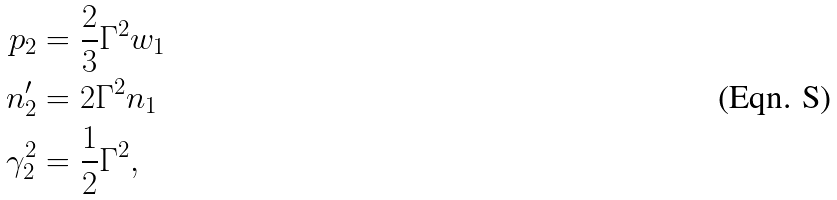<formula> <loc_0><loc_0><loc_500><loc_500>p _ { 2 } & = \frac { 2 } { 3 } \Gamma ^ { 2 } w _ { 1 } \\ n _ { 2 } ^ { \prime } & = 2 \Gamma ^ { 2 } n _ { 1 } \\ \gamma _ { 2 } ^ { 2 } & = \frac { 1 } { 2 } \Gamma ^ { 2 } ,</formula> 